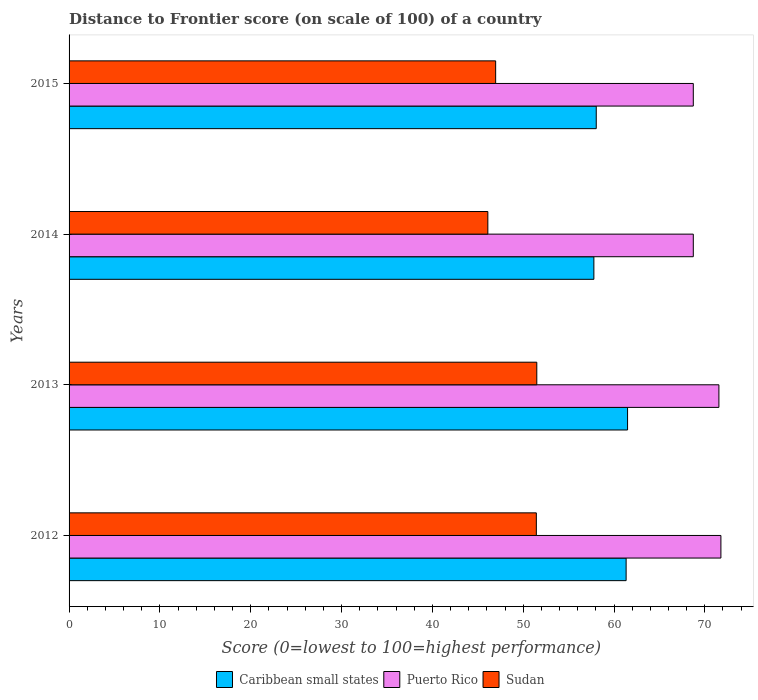How many bars are there on the 1st tick from the top?
Keep it short and to the point. 3. What is the label of the 2nd group of bars from the top?
Offer a terse response. 2014. In how many cases, is the number of bars for a given year not equal to the number of legend labels?
Your answer should be compact. 0. What is the distance to frontier score of in Sudan in 2012?
Offer a terse response. 51.45. Across all years, what is the maximum distance to frontier score of in Caribbean small states?
Your answer should be very brief. 61.49. Across all years, what is the minimum distance to frontier score of in Puerto Rico?
Give a very brief answer. 68.73. In which year was the distance to frontier score of in Caribbean small states minimum?
Give a very brief answer. 2014. What is the total distance to frontier score of in Sudan in the graph?
Your response must be concise. 196.03. What is the difference between the distance to frontier score of in Caribbean small states in 2012 and that in 2013?
Ensure brevity in your answer.  -0.16. What is the difference between the distance to frontier score of in Sudan in 2014 and the distance to frontier score of in Puerto Rico in 2015?
Offer a very short reply. -22.62. What is the average distance to frontier score of in Caribbean small states per year?
Give a very brief answer. 59.66. In the year 2015, what is the difference between the distance to frontier score of in Puerto Rico and distance to frontier score of in Caribbean small states?
Provide a short and direct response. 10.68. What is the ratio of the distance to frontier score of in Puerto Rico in 2013 to that in 2014?
Your response must be concise. 1.04. Is the distance to frontier score of in Sudan in 2013 less than that in 2015?
Offer a terse response. No. What is the difference between the highest and the second highest distance to frontier score of in Puerto Rico?
Provide a succinct answer. 0.22. What is the difference between the highest and the lowest distance to frontier score of in Sudan?
Provide a succinct answer. 5.39. What does the 3rd bar from the top in 2013 represents?
Offer a terse response. Caribbean small states. What does the 1st bar from the bottom in 2015 represents?
Keep it short and to the point. Caribbean small states. Are all the bars in the graph horizontal?
Offer a very short reply. Yes. How many years are there in the graph?
Provide a short and direct response. 4. Does the graph contain any zero values?
Your answer should be very brief. No. How many legend labels are there?
Provide a succinct answer. 3. How are the legend labels stacked?
Offer a very short reply. Horizontal. What is the title of the graph?
Offer a very short reply. Distance to Frontier score (on scale of 100) of a country. What is the label or title of the X-axis?
Make the answer very short. Score (0=lowest to 100=highest performance). What is the Score (0=lowest to 100=highest performance) in Caribbean small states in 2012?
Your response must be concise. 61.33. What is the Score (0=lowest to 100=highest performance) in Puerto Rico in 2012?
Provide a short and direct response. 71.77. What is the Score (0=lowest to 100=highest performance) in Sudan in 2012?
Ensure brevity in your answer.  51.45. What is the Score (0=lowest to 100=highest performance) in Caribbean small states in 2013?
Provide a succinct answer. 61.49. What is the Score (0=lowest to 100=highest performance) of Puerto Rico in 2013?
Ensure brevity in your answer.  71.55. What is the Score (0=lowest to 100=highest performance) in Sudan in 2013?
Your answer should be very brief. 51.5. What is the Score (0=lowest to 100=highest performance) of Caribbean small states in 2014?
Your response must be concise. 57.78. What is the Score (0=lowest to 100=highest performance) in Puerto Rico in 2014?
Your response must be concise. 68.73. What is the Score (0=lowest to 100=highest performance) in Sudan in 2014?
Your answer should be compact. 46.11. What is the Score (0=lowest to 100=highest performance) of Caribbean small states in 2015?
Ensure brevity in your answer.  58.05. What is the Score (0=lowest to 100=highest performance) of Puerto Rico in 2015?
Make the answer very short. 68.73. What is the Score (0=lowest to 100=highest performance) of Sudan in 2015?
Provide a short and direct response. 46.97. Across all years, what is the maximum Score (0=lowest to 100=highest performance) of Caribbean small states?
Give a very brief answer. 61.49. Across all years, what is the maximum Score (0=lowest to 100=highest performance) of Puerto Rico?
Your response must be concise. 71.77. Across all years, what is the maximum Score (0=lowest to 100=highest performance) of Sudan?
Your answer should be compact. 51.5. Across all years, what is the minimum Score (0=lowest to 100=highest performance) in Caribbean small states?
Make the answer very short. 57.78. Across all years, what is the minimum Score (0=lowest to 100=highest performance) of Puerto Rico?
Keep it short and to the point. 68.73. Across all years, what is the minimum Score (0=lowest to 100=highest performance) in Sudan?
Ensure brevity in your answer.  46.11. What is the total Score (0=lowest to 100=highest performance) in Caribbean small states in the graph?
Offer a very short reply. 238.66. What is the total Score (0=lowest to 100=highest performance) in Puerto Rico in the graph?
Give a very brief answer. 280.78. What is the total Score (0=lowest to 100=highest performance) in Sudan in the graph?
Make the answer very short. 196.03. What is the difference between the Score (0=lowest to 100=highest performance) of Caribbean small states in 2012 and that in 2013?
Offer a terse response. -0.16. What is the difference between the Score (0=lowest to 100=highest performance) in Puerto Rico in 2012 and that in 2013?
Provide a short and direct response. 0.22. What is the difference between the Score (0=lowest to 100=highest performance) of Sudan in 2012 and that in 2013?
Offer a terse response. -0.05. What is the difference between the Score (0=lowest to 100=highest performance) in Caribbean small states in 2012 and that in 2014?
Keep it short and to the point. 3.55. What is the difference between the Score (0=lowest to 100=highest performance) of Puerto Rico in 2012 and that in 2014?
Provide a short and direct response. 3.04. What is the difference between the Score (0=lowest to 100=highest performance) of Sudan in 2012 and that in 2014?
Keep it short and to the point. 5.34. What is the difference between the Score (0=lowest to 100=highest performance) of Caribbean small states in 2012 and that in 2015?
Provide a short and direct response. 3.29. What is the difference between the Score (0=lowest to 100=highest performance) in Puerto Rico in 2012 and that in 2015?
Make the answer very short. 3.04. What is the difference between the Score (0=lowest to 100=highest performance) in Sudan in 2012 and that in 2015?
Offer a very short reply. 4.48. What is the difference between the Score (0=lowest to 100=highest performance) of Caribbean small states in 2013 and that in 2014?
Offer a terse response. 3.71. What is the difference between the Score (0=lowest to 100=highest performance) of Puerto Rico in 2013 and that in 2014?
Offer a very short reply. 2.82. What is the difference between the Score (0=lowest to 100=highest performance) in Sudan in 2013 and that in 2014?
Keep it short and to the point. 5.39. What is the difference between the Score (0=lowest to 100=highest performance) in Caribbean small states in 2013 and that in 2015?
Your answer should be very brief. 3.45. What is the difference between the Score (0=lowest to 100=highest performance) of Puerto Rico in 2013 and that in 2015?
Your answer should be very brief. 2.82. What is the difference between the Score (0=lowest to 100=highest performance) of Sudan in 2013 and that in 2015?
Your response must be concise. 4.53. What is the difference between the Score (0=lowest to 100=highest performance) in Caribbean small states in 2014 and that in 2015?
Your answer should be very brief. -0.26. What is the difference between the Score (0=lowest to 100=highest performance) in Puerto Rico in 2014 and that in 2015?
Your answer should be compact. 0. What is the difference between the Score (0=lowest to 100=highest performance) in Sudan in 2014 and that in 2015?
Provide a succinct answer. -0.86. What is the difference between the Score (0=lowest to 100=highest performance) of Caribbean small states in 2012 and the Score (0=lowest to 100=highest performance) of Puerto Rico in 2013?
Keep it short and to the point. -10.22. What is the difference between the Score (0=lowest to 100=highest performance) in Caribbean small states in 2012 and the Score (0=lowest to 100=highest performance) in Sudan in 2013?
Your answer should be compact. 9.83. What is the difference between the Score (0=lowest to 100=highest performance) in Puerto Rico in 2012 and the Score (0=lowest to 100=highest performance) in Sudan in 2013?
Ensure brevity in your answer.  20.27. What is the difference between the Score (0=lowest to 100=highest performance) in Caribbean small states in 2012 and the Score (0=lowest to 100=highest performance) in Puerto Rico in 2014?
Your answer should be very brief. -7.4. What is the difference between the Score (0=lowest to 100=highest performance) in Caribbean small states in 2012 and the Score (0=lowest to 100=highest performance) in Sudan in 2014?
Your response must be concise. 15.22. What is the difference between the Score (0=lowest to 100=highest performance) in Puerto Rico in 2012 and the Score (0=lowest to 100=highest performance) in Sudan in 2014?
Provide a succinct answer. 25.66. What is the difference between the Score (0=lowest to 100=highest performance) in Caribbean small states in 2012 and the Score (0=lowest to 100=highest performance) in Puerto Rico in 2015?
Provide a short and direct response. -7.4. What is the difference between the Score (0=lowest to 100=highest performance) of Caribbean small states in 2012 and the Score (0=lowest to 100=highest performance) of Sudan in 2015?
Keep it short and to the point. 14.36. What is the difference between the Score (0=lowest to 100=highest performance) in Puerto Rico in 2012 and the Score (0=lowest to 100=highest performance) in Sudan in 2015?
Offer a very short reply. 24.8. What is the difference between the Score (0=lowest to 100=highest performance) of Caribbean small states in 2013 and the Score (0=lowest to 100=highest performance) of Puerto Rico in 2014?
Your answer should be very brief. -7.24. What is the difference between the Score (0=lowest to 100=highest performance) in Caribbean small states in 2013 and the Score (0=lowest to 100=highest performance) in Sudan in 2014?
Offer a terse response. 15.38. What is the difference between the Score (0=lowest to 100=highest performance) of Puerto Rico in 2013 and the Score (0=lowest to 100=highest performance) of Sudan in 2014?
Your response must be concise. 25.44. What is the difference between the Score (0=lowest to 100=highest performance) in Caribbean small states in 2013 and the Score (0=lowest to 100=highest performance) in Puerto Rico in 2015?
Provide a short and direct response. -7.24. What is the difference between the Score (0=lowest to 100=highest performance) in Caribbean small states in 2013 and the Score (0=lowest to 100=highest performance) in Sudan in 2015?
Ensure brevity in your answer.  14.52. What is the difference between the Score (0=lowest to 100=highest performance) in Puerto Rico in 2013 and the Score (0=lowest to 100=highest performance) in Sudan in 2015?
Offer a terse response. 24.58. What is the difference between the Score (0=lowest to 100=highest performance) in Caribbean small states in 2014 and the Score (0=lowest to 100=highest performance) in Puerto Rico in 2015?
Offer a very short reply. -10.95. What is the difference between the Score (0=lowest to 100=highest performance) in Caribbean small states in 2014 and the Score (0=lowest to 100=highest performance) in Sudan in 2015?
Offer a very short reply. 10.81. What is the difference between the Score (0=lowest to 100=highest performance) in Puerto Rico in 2014 and the Score (0=lowest to 100=highest performance) in Sudan in 2015?
Your answer should be compact. 21.76. What is the average Score (0=lowest to 100=highest performance) of Caribbean small states per year?
Provide a succinct answer. 59.66. What is the average Score (0=lowest to 100=highest performance) in Puerto Rico per year?
Your response must be concise. 70.19. What is the average Score (0=lowest to 100=highest performance) in Sudan per year?
Ensure brevity in your answer.  49.01. In the year 2012, what is the difference between the Score (0=lowest to 100=highest performance) in Caribbean small states and Score (0=lowest to 100=highest performance) in Puerto Rico?
Offer a terse response. -10.44. In the year 2012, what is the difference between the Score (0=lowest to 100=highest performance) of Caribbean small states and Score (0=lowest to 100=highest performance) of Sudan?
Offer a terse response. 9.88. In the year 2012, what is the difference between the Score (0=lowest to 100=highest performance) in Puerto Rico and Score (0=lowest to 100=highest performance) in Sudan?
Offer a very short reply. 20.32. In the year 2013, what is the difference between the Score (0=lowest to 100=highest performance) in Caribbean small states and Score (0=lowest to 100=highest performance) in Puerto Rico?
Give a very brief answer. -10.06. In the year 2013, what is the difference between the Score (0=lowest to 100=highest performance) in Caribbean small states and Score (0=lowest to 100=highest performance) in Sudan?
Give a very brief answer. 9.99. In the year 2013, what is the difference between the Score (0=lowest to 100=highest performance) in Puerto Rico and Score (0=lowest to 100=highest performance) in Sudan?
Offer a very short reply. 20.05. In the year 2014, what is the difference between the Score (0=lowest to 100=highest performance) of Caribbean small states and Score (0=lowest to 100=highest performance) of Puerto Rico?
Provide a succinct answer. -10.95. In the year 2014, what is the difference between the Score (0=lowest to 100=highest performance) in Caribbean small states and Score (0=lowest to 100=highest performance) in Sudan?
Your response must be concise. 11.67. In the year 2014, what is the difference between the Score (0=lowest to 100=highest performance) of Puerto Rico and Score (0=lowest to 100=highest performance) of Sudan?
Provide a short and direct response. 22.62. In the year 2015, what is the difference between the Score (0=lowest to 100=highest performance) in Caribbean small states and Score (0=lowest to 100=highest performance) in Puerto Rico?
Keep it short and to the point. -10.68. In the year 2015, what is the difference between the Score (0=lowest to 100=highest performance) in Caribbean small states and Score (0=lowest to 100=highest performance) in Sudan?
Provide a short and direct response. 11.08. In the year 2015, what is the difference between the Score (0=lowest to 100=highest performance) in Puerto Rico and Score (0=lowest to 100=highest performance) in Sudan?
Your response must be concise. 21.76. What is the ratio of the Score (0=lowest to 100=highest performance) of Caribbean small states in 2012 to that in 2014?
Your response must be concise. 1.06. What is the ratio of the Score (0=lowest to 100=highest performance) in Puerto Rico in 2012 to that in 2014?
Your answer should be compact. 1.04. What is the ratio of the Score (0=lowest to 100=highest performance) in Sudan in 2012 to that in 2014?
Make the answer very short. 1.12. What is the ratio of the Score (0=lowest to 100=highest performance) of Caribbean small states in 2012 to that in 2015?
Offer a terse response. 1.06. What is the ratio of the Score (0=lowest to 100=highest performance) in Puerto Rico in 2012 to that in 2015?
Ensure brevity in your answer.  1.04. What is the ratio of the Score (0=lowest to 100=highest performance) in Sudan in 2012 to that in 2015?
Your answer should be compact. 1.1. What is the ratio of the Score (0=lowest to 100=highest performance) in Caribbean small states in 2013 to that in 2014?
Make the answer very short. 1.06. What is the ratio of the Score (0=lowest to 100=highest performance) of Puerto Rico in 2013 to that in 2014?
Give a very brief answer. 1.04. What is the ratio of the Score (0=lowest to 100=highest performance) in Sudan in 2013 to that in 2014?
Offer a terse response. 1.12. What is the ratio of the Score (0=lowest to 100=highest performance) of Caribbean small states in 2013 to that in 2015?
Provide a short and direct response. 1.06. What is the ratio of the Score (0=lowest to 100=highest performance) of Puerto Rico in 2013 to that in 2015?
Your answer should be compact. 1.04. What is the ratio of the Score (0=lowest to 100=highest performance) of Sudan in 2013 to that in 2015?
Your answer should be compact. 1.1. What is the ratio of the Score (0=lowest to 100=highest performance) in Caribbean small states in 2014 to that in 2015?
Provide a succinct answer. 1. What is the ratio of the Score (0=lowest to 100=highest performance) of Sudan in 2014 to that in 2015?
Ensure brevity in your answer.  0.98. What is the difference between the highest and the second highest Score (0=lowest to 100=highest performance) of Caribbean small states?
Your response must be concise. 0.16. What is the difference between the highest and the second highest Score (0=lowest to 100=highest performance) in Puerto Rico?
Provide a short and direct response. 0.22. What is the difference between the highest and the second highest Score (0=lowest to 100=highest performance) in Sudan?
Offer a very short reply. 0.05. What is the difference between the highest and the lowest Score (0=lowest to 100=highest performance) of Caribbean small states?
Ensure brevity in your answer.  3.71. What is the difference between the highest and the lowest Score (0=lowest to 100=highest performance) in Puerto Rico?
Provide a short and direct response. 3.04. What is the difference between the highest and the lowest Score (0=lowest to 100=highest performance) in Sudan?
Your answer should be very brief. 5.39. 